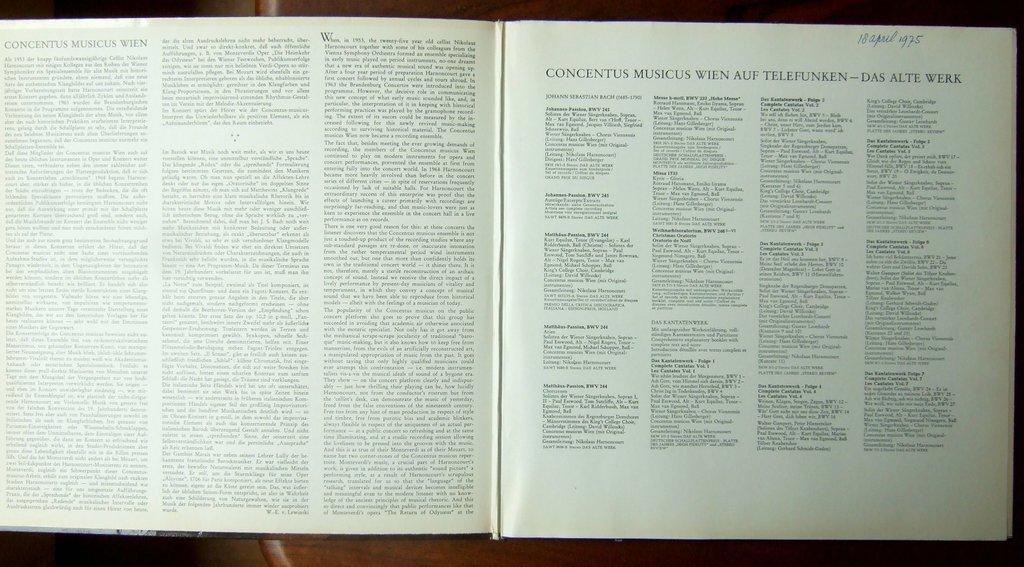What date is hand written at the top of the page on the right?
Offer a very short reply. 18 april 1975. 